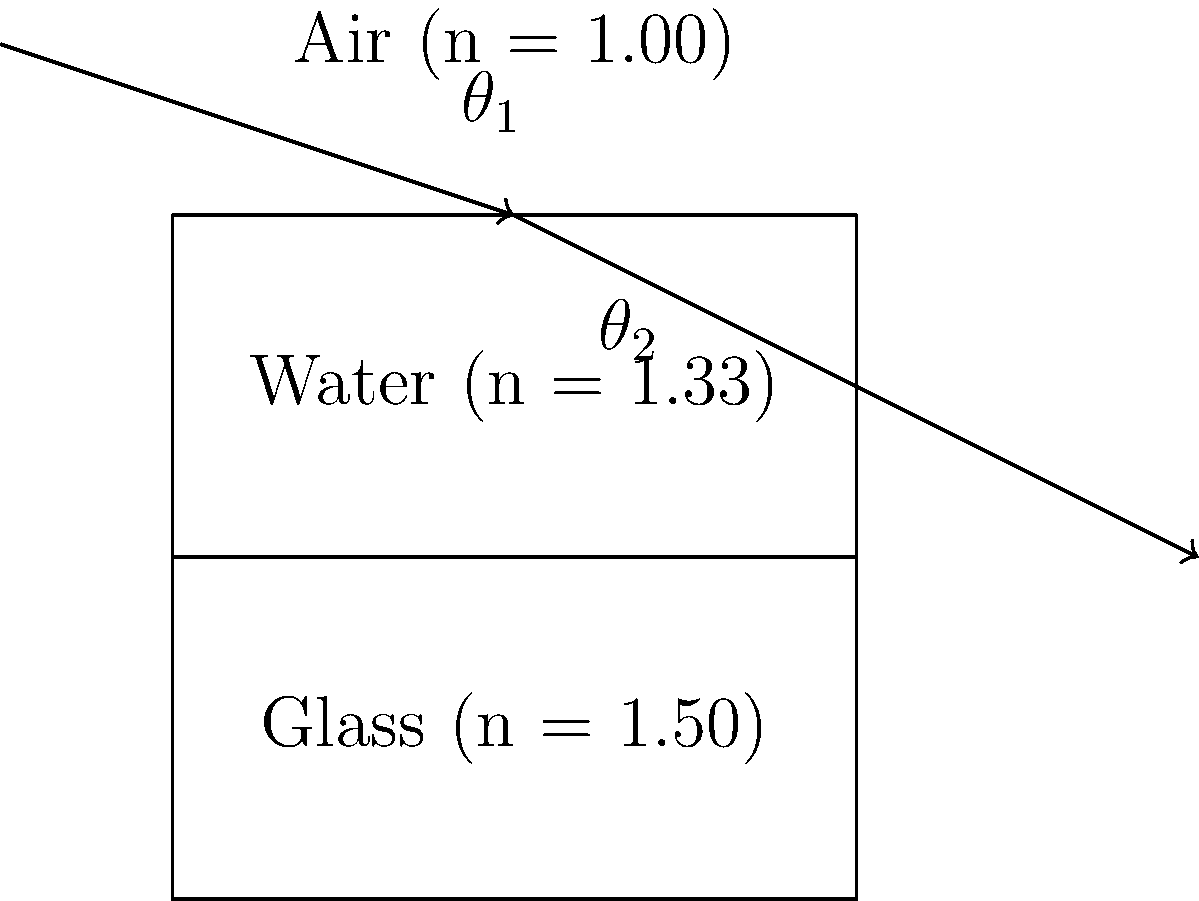You're reading an e-book about optics on your tablet when you come across a question about light refraction. The diagram shows a light ray passing through three different mediums: air, water, and glass. If the angle of incidence in air is 45°, what is the angle of refraction when the light enters the glass? Let's approach this step-by-step using Snell's law:

1) First, we need to use Snell's law to find the angle of refraction in water:

   $$n_1 \sin(\theta_1) = n_2 \sin(\theta_2)$$

   Where $n_1 = 1.00$ (air), $n_2 = 1.33$ (water), and $\theta_1 = 45°$

2) Substituting these values:

   $$1.00 \sin(45°) = 1.33 \sin(\theta_2)$$

3) Solving for $\theta_2$:

   $$\sin(\theta_2) = \frac{1.00 \sin(45°)}{1.33} = 0.5303$$
   $$\theta_2 = \arcsin(0.5303) = 32.0°$$

4) Now we use Snell's law again, this time for the water-glass interface:

   $$n_2 \sin(\theta_2) = n_3 \sin(\theta_3)$$

   Where $n_2 = 1.33$ (water), $n_3 = 1.50$ (glass), and $\theta_2 = 32.0°$

5) Substituting these values:

   $$1.33 \sin(32.0°) = 1.50 \sin(\theta_3)$$

6) Solving for $\theta_3$:

   $$\sin(\theta_3) = \frac{1.33 \sin(32.0°)}{1.50} = 0.4702$$
   $$\theta_3 = \arcsin(0.4702) = 28.1°$$

Therefore, the angle of refraction when the light enters the glass is approximately 28.1°.
Answer: 28.1° 